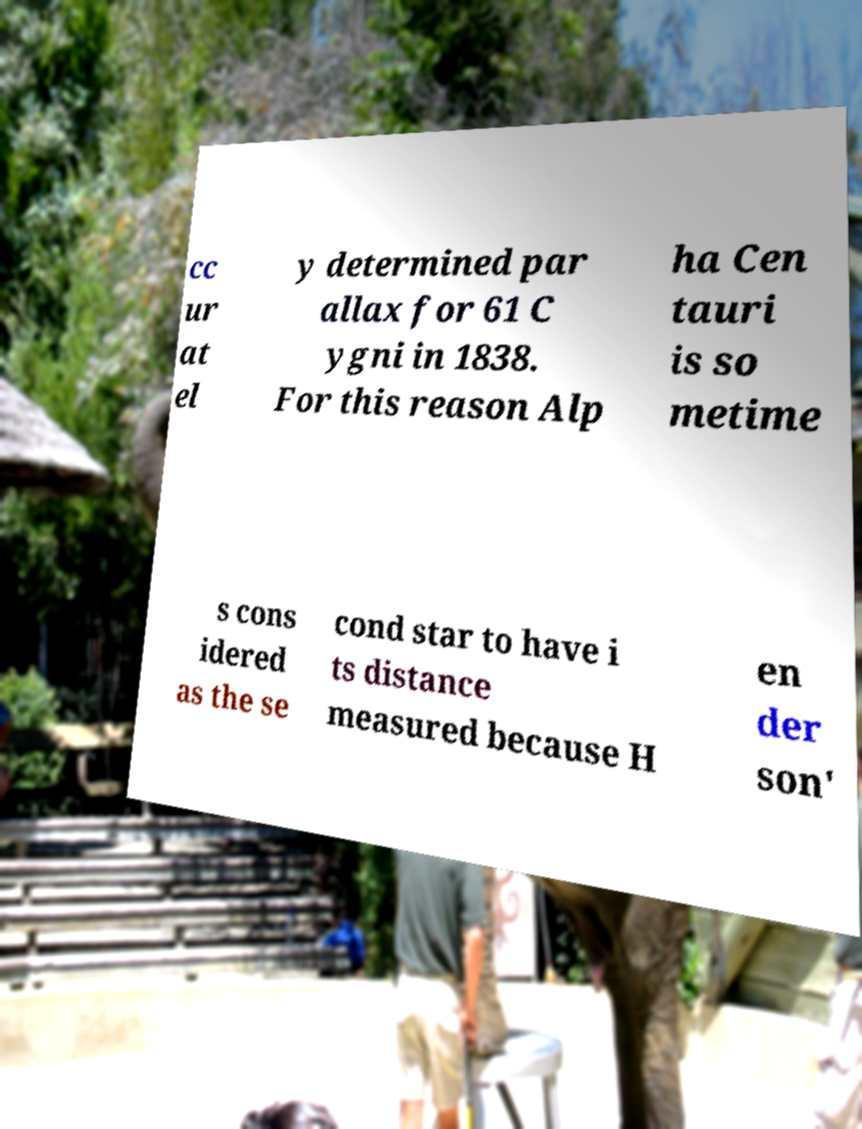Can you accurately transcribe the text from the provided image for me? cc ur at el y determined par allax for 61 C ygni in 1838. For this reason Alp ha Cen tauri is so metime s cons idered as the se cond star to have i ts distance measured because H en der son' 